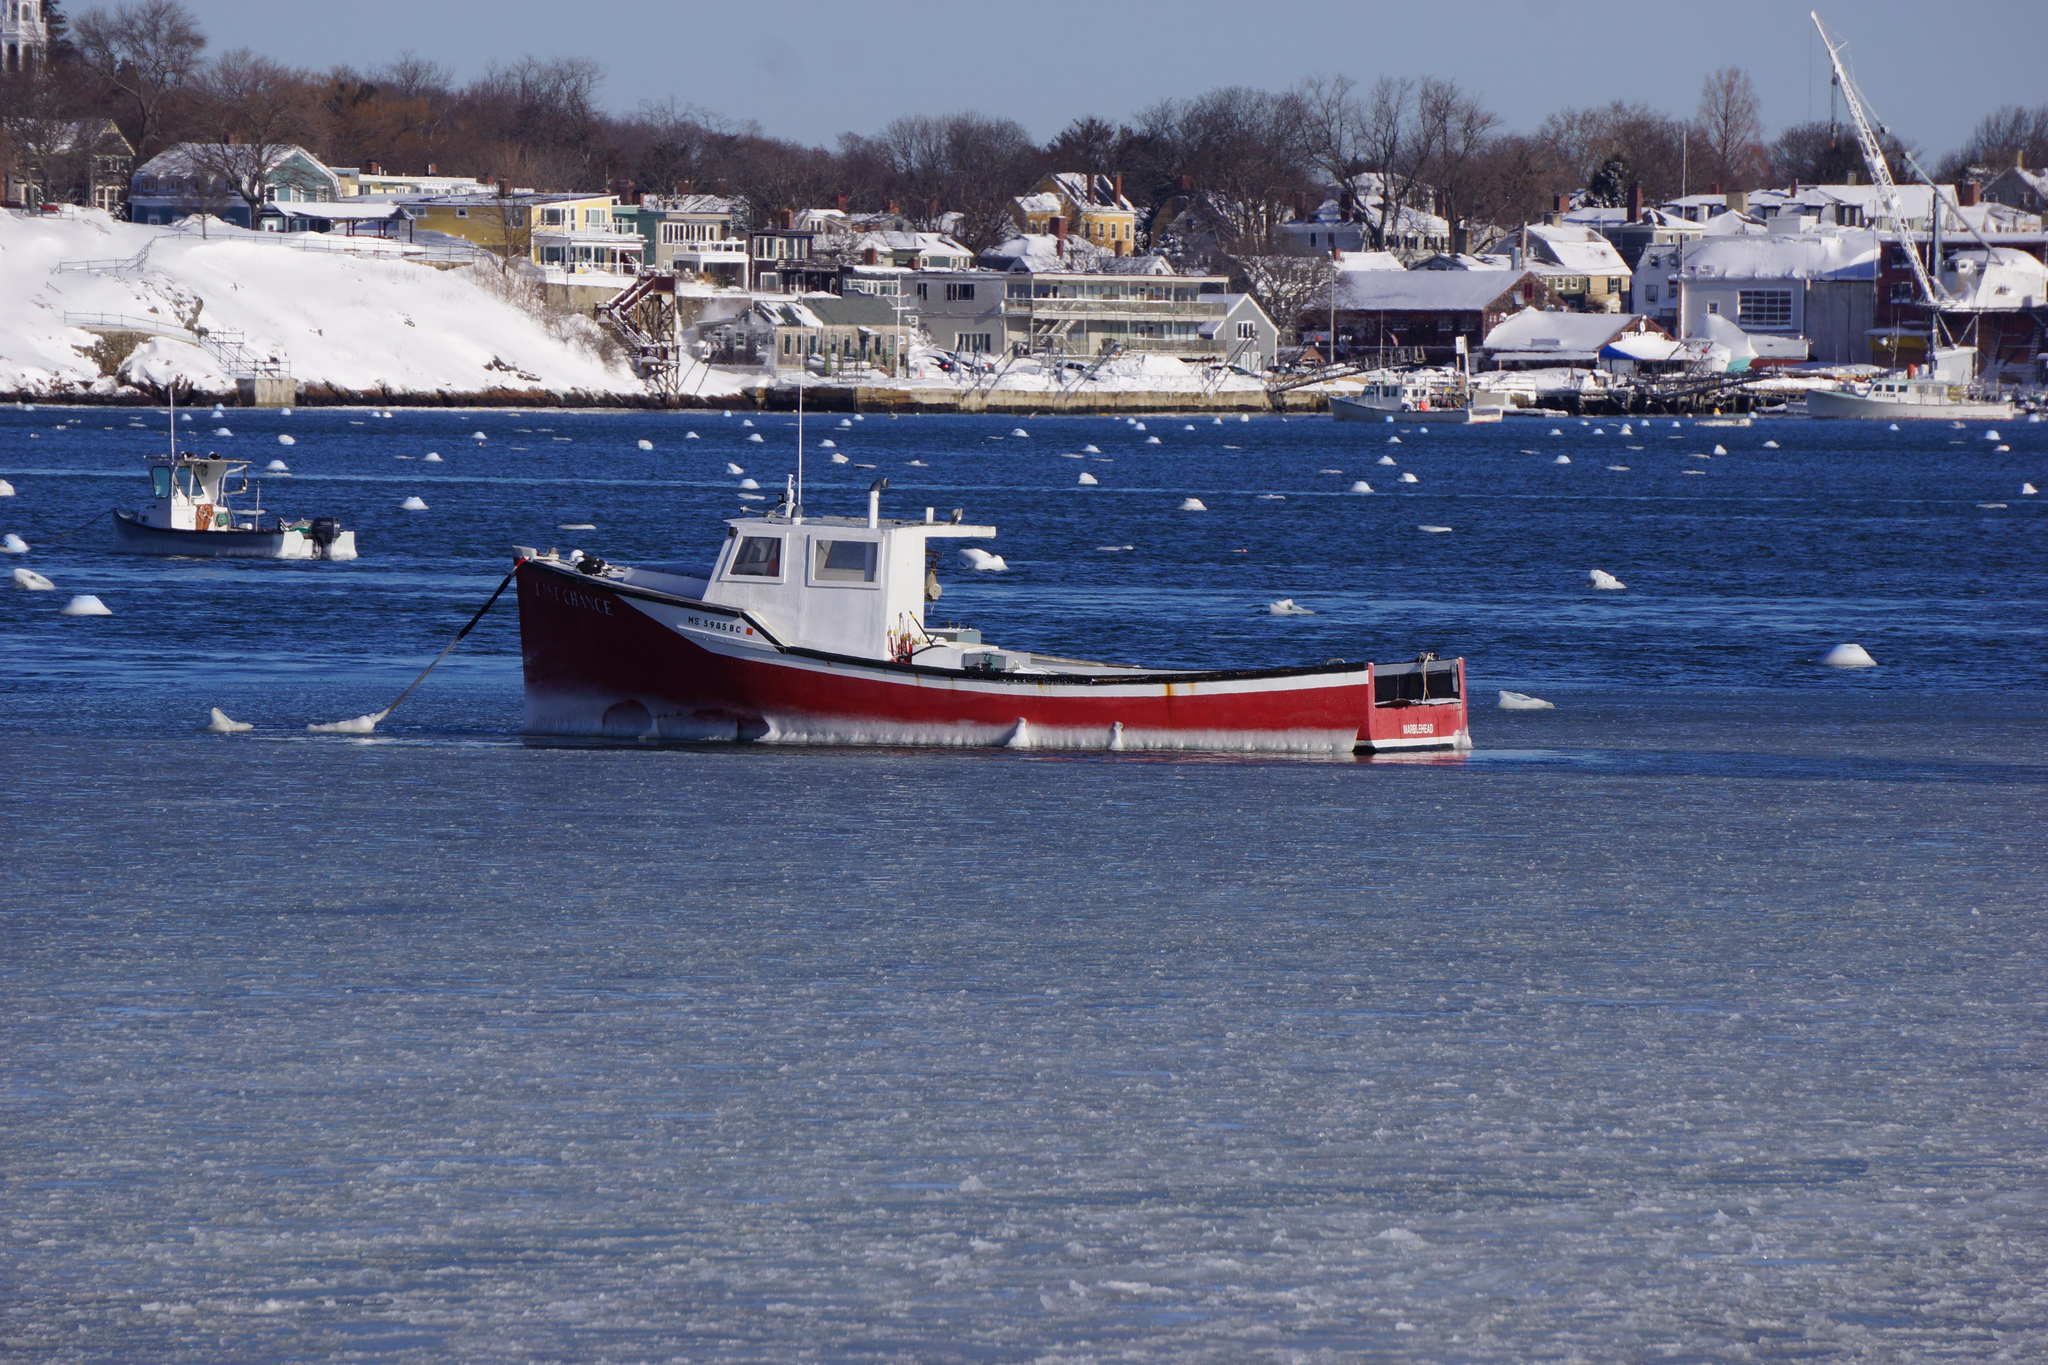What is on the water in the image? There are boats on the water in the image. What can be seen in the background of the image? There are buildings, trees, and poles in the background of the image. What is the weather like in the image? There is snow visible in the image, and there are clouds in the sky at the top of the image. Where is the aunt located in the image? There is no aunt present in the image. What type of bell can be heard ringing in the image? There is no bell present in the image, and therefore no sound can be heard. 